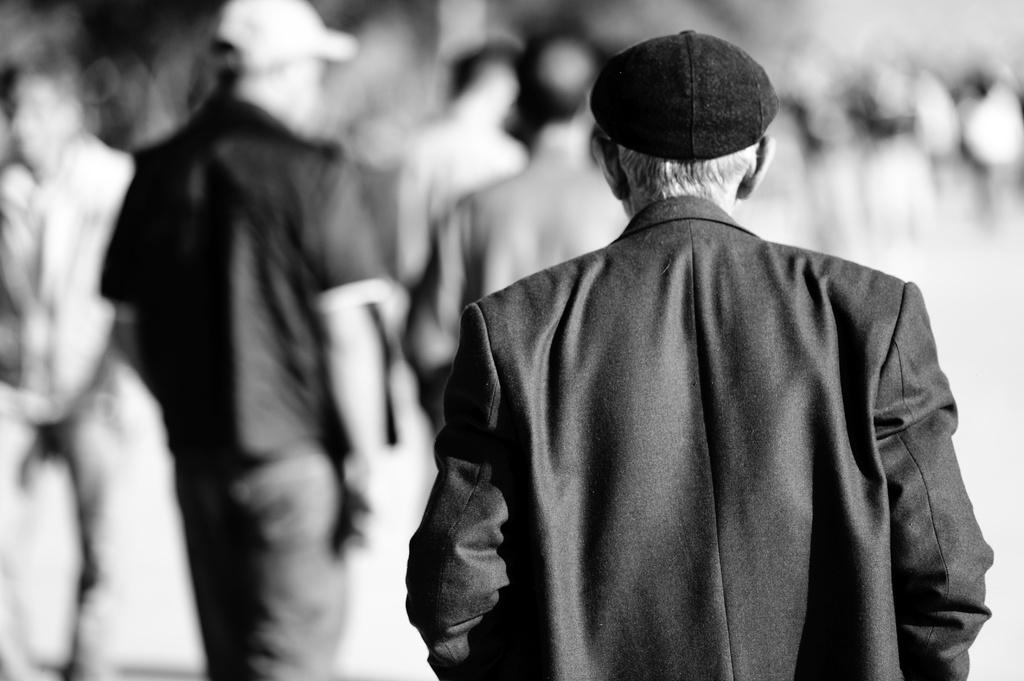What is the main subject in the foreground of the image? There is a man in the foreground of the image. What is the man wearing? The man is wearing a black suit. What is the man doing in the image? The man appears to be walking on the ground. What can be seen in the background of the image? There are persons in the background of the image. What type of hat is the man wearing in the image? The man is not wearing a hat in the image. Is there an umbrella visible in the image? There is no umbrella present in the image. 